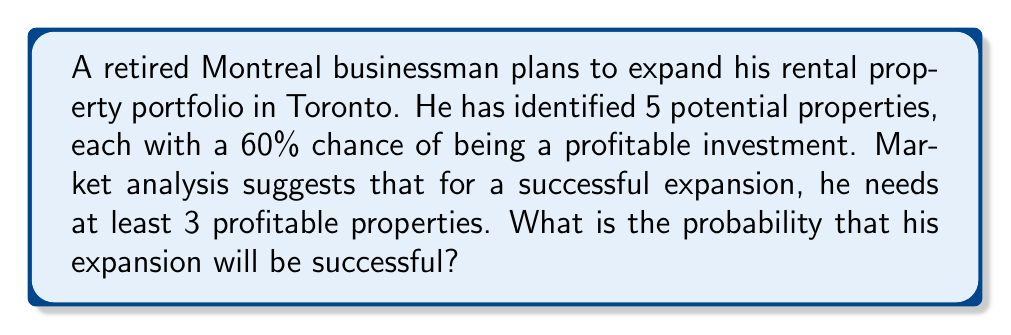Provide a solution to this math problem. To solve this problem, we need to use the binomial probability distribution:

1) We have n = 5 trials (properties)
2) The probability of success (profitable property) for each trial is p = 0.6
3) We need at least k = 3 successes for a successful expansion

The probability of exactly k successes in n trials is given by:

$$P(X = k) = \binom{n}{k} p^k (1-p)^{n-k}$$

We need to sum this probability for k = 3, 4, and 5:

$$P(X \geq 3) = P(X = 3) + P(X = 4) + P(X = 5)$$

Let's calculate each term:

For k = 3:
$$P(X = 3) = \binom{5}{3} (0.6)^3 (0.4)^2 = 10 \cdot 0.216 \cdot 0.16 = 0.3456$$

For k = 4:
$$P(X = 4) = \binom{5}{4} (0.6)^4 (0.4)^1 = 5 \cdot 0.1296 \cdot 0.4 = 0.2592$$

For k = 5:
$$P(X = 5) = \binom{5}{5} (0.6)^5 (0.4)^0 = 1 \cdot 0.07776 \cdot 1 = 0.07776$$

Now, we sum these probabilities:

$$P(X \geq 3) = 0.3456 + 0.2592 + 0.07776 = 0.68256$$
Answer: 0.68256 